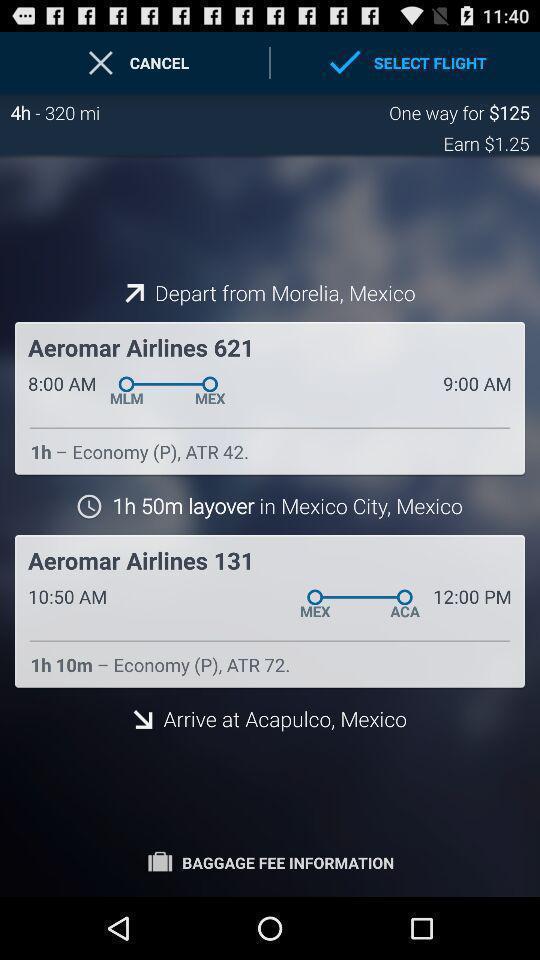Summarize the information in this screenshot. Screen asks to select flights. 